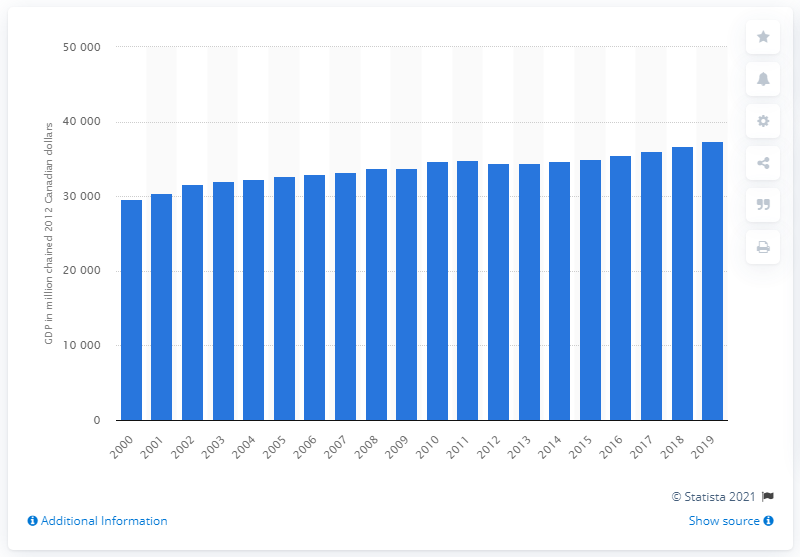List a handful of essential elements in this visual. In 2019, the gross domestic product (GDP) of Nova Scotia was approximately 37,441 million dollars. 